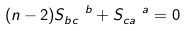<formula> <loc_0><loc_0><loc_500><loc_500>( n - 2 ) S _ { b c } ^ { \ \ b } + S _ { c a } ^ { \ \ a } = 0</formula> 